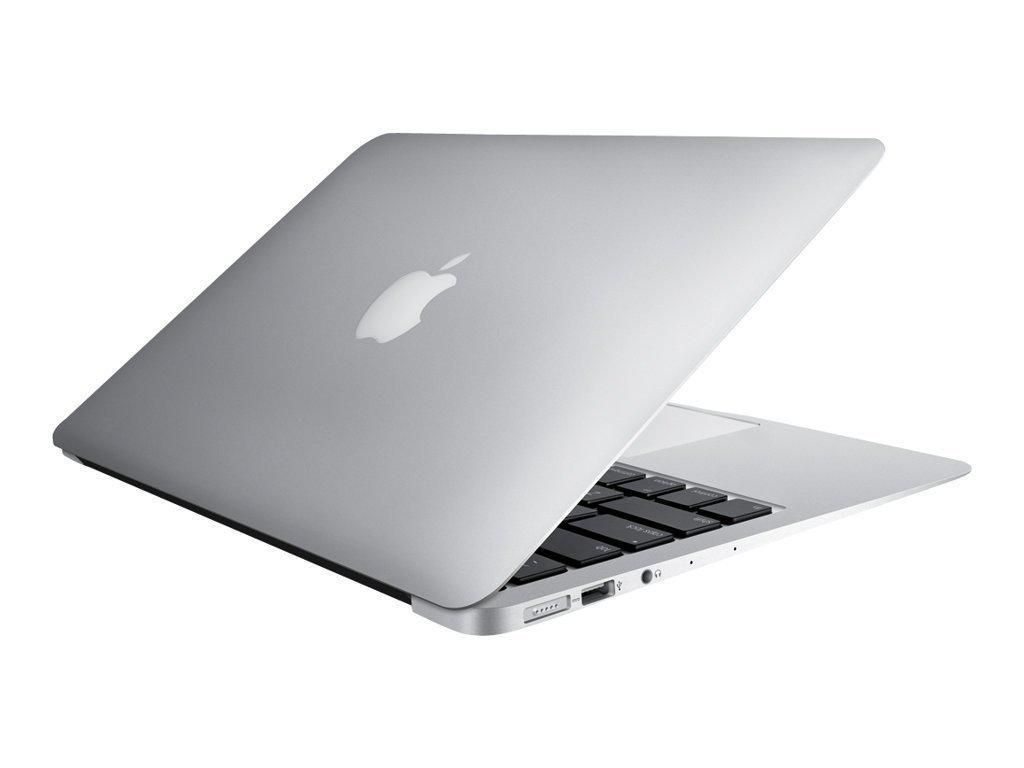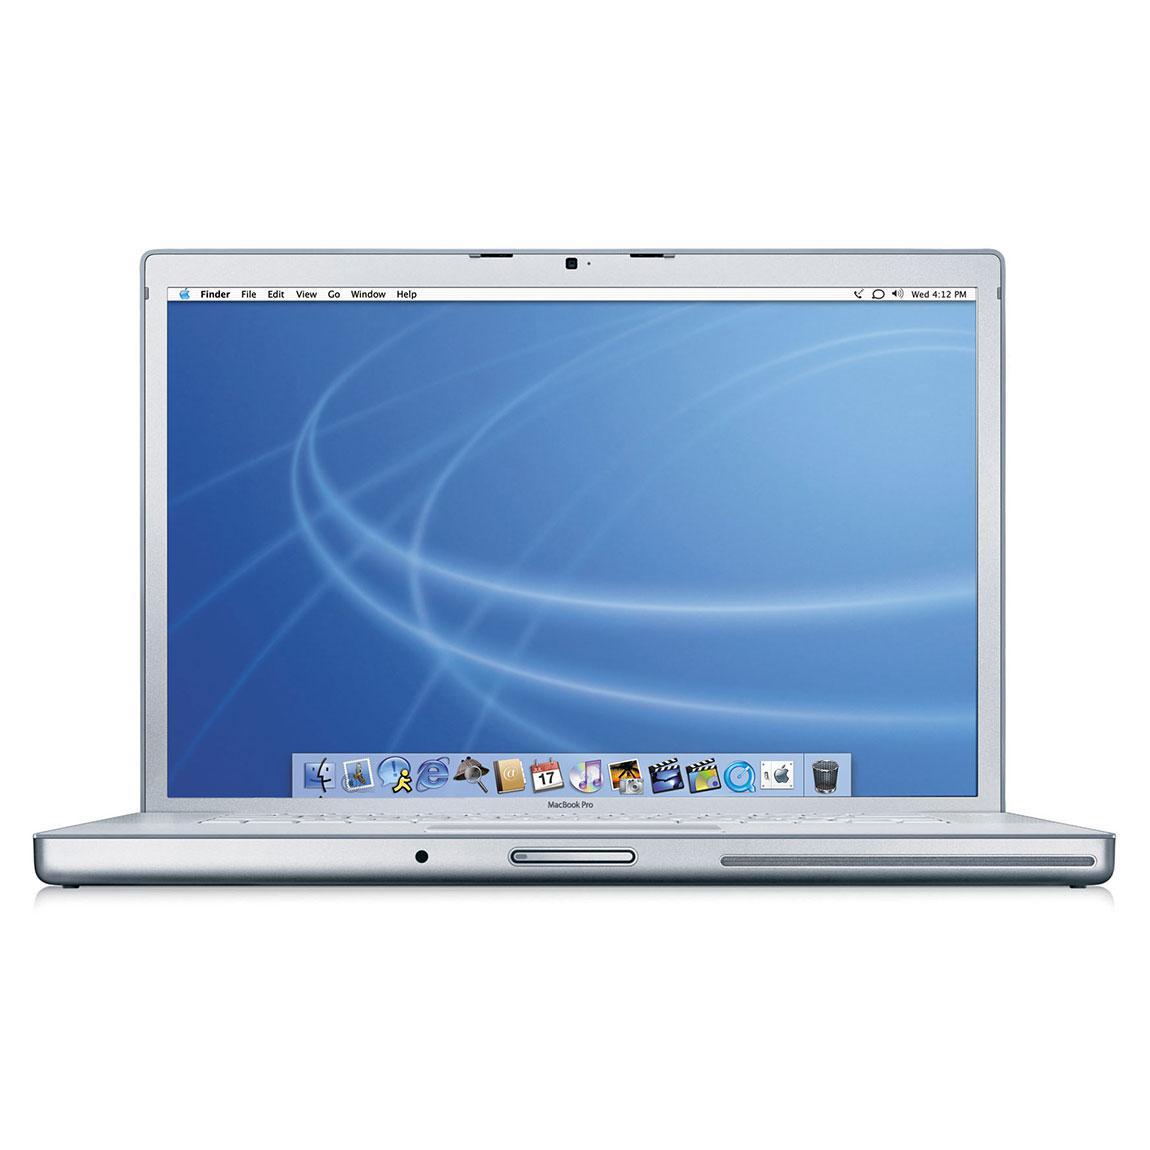The first image is the image on the left, the second image is the image on the right. For the images displayed, is the sentence "Each image contains one device displayed so the screen is visible, and each screen has the same glowing violet and blue picture on it." factually correct? Answer yes or no. No. The first image is the image on the left, the second image is the image on the right. Assess this claim about the two images: "The left and right image contains the same number of fully open laptops.". Correct or not? Answer yes or no. No. 